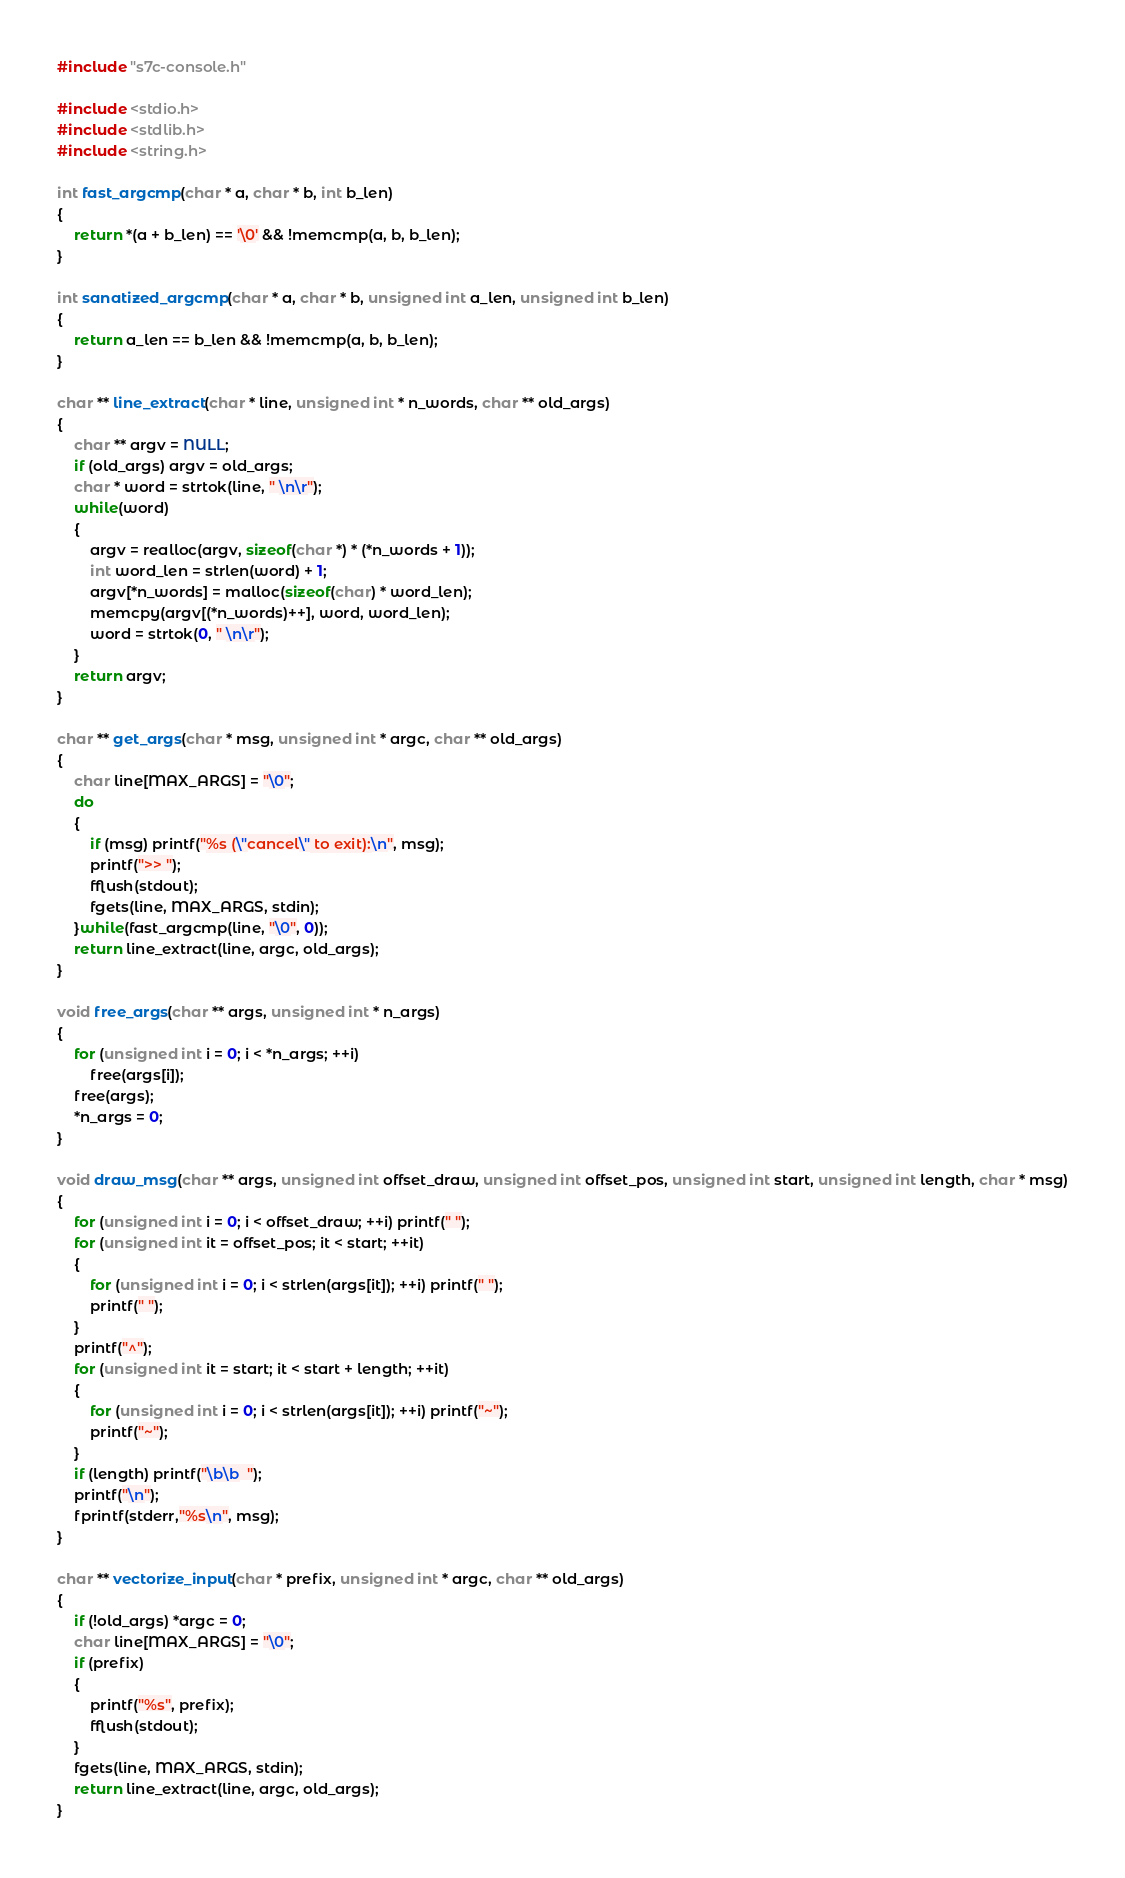<code> <loc_0><loc_0><loc_500><loc_500><_C_>#include "s7c-console.h"

#include <stdio.h>
#include <stdlib.h>
#include <string.h>

int fast_argcmp(char * a, char * b, int b_len)
{
    return *(a + b_len) == '\0' && !memcmp(a, b, b_len);
}

int sanatized_argcmp(char * a, char * b, unsigned int a_len, unsigned int b_len)
{
    return a_len == b_len && !memcmp(a, b, b_len);
}

char ** line_extract(char * line, unsigned int * n_words, char ** old_args)
{
    char ** argv = NULL;
    if (old_args) argv = old_args;
    char * word = strtok(line, " \n\r");
    while(word)
    {
        argv = realloc(argv, sizeof(char *) * (*n_words + 1));
        int word_len = strlen(word) + 1;
        argv[*n_words] = malloc(sizeof(char) * word_len);
        memcpy(argv[(*n_words)++], word, word_len);
        word = strtok(0, " \n\r");
    }
    return argv;
}

char ** get_args(char * msg, unsigned int * argc, char ** old_args)
{
    char line[MAX_ARGS] = "\0";
    do
    {
        if (msg) printf("%s (\"cancel\" to exit):\n", msg);
        printf(">> ");
        fflush(stdout);
        fgets(line, MAX_ARGS, stdin);
    }while(fast_argcmp(line, "\0", 0));
    return line_extract(line, argc, old_args);
}

void free_args(char ** args, unsigned int * n_args)
{
    for (unsigned int i = 0; i < *n_args; ++i)
        free(args[i]);
    free(args);
    *n_args = 0;
}

void draw_msg(char ** args, unsigned int offset_draw, unsigned int offset_pos, unsigned int start, unsigned int length, char * msg)
{
    for (unsigned int i = 0; i < offset_draw; ++i) printf(" ");
    for (unsigned int it = offset_pos; it < start; ++it)
    {
        for (unsigned int i = 0; i < strlen(args[it]); ++i) printf(" ");
        printf(" ");
    }
    printf("^");
    for (unsigned int it = start; it < start + length; ++it)
    {
        for (unsigned int i = 0; i < strlen(args[it]); ++i) printf("~");
        printf("~");
    }
    if (length) printf("\b\b  ");
    printf("\n");
    fprintf(stderr,"%s\n", msg);
}

char ** vectorize_input(char * prefix, unsigned int * argc, char ** old_args)
{
    if (!old_args) *argc = 0;
    char line[MAX_ARGS] = "\0";
    if (prefix)
    {
        printf("%s", prefix);
        fflush(stdout);
    }
    fgets(line, MAX_ARGS, stdin);
    return line_extract(line, argc, old_args);
}
</code> 